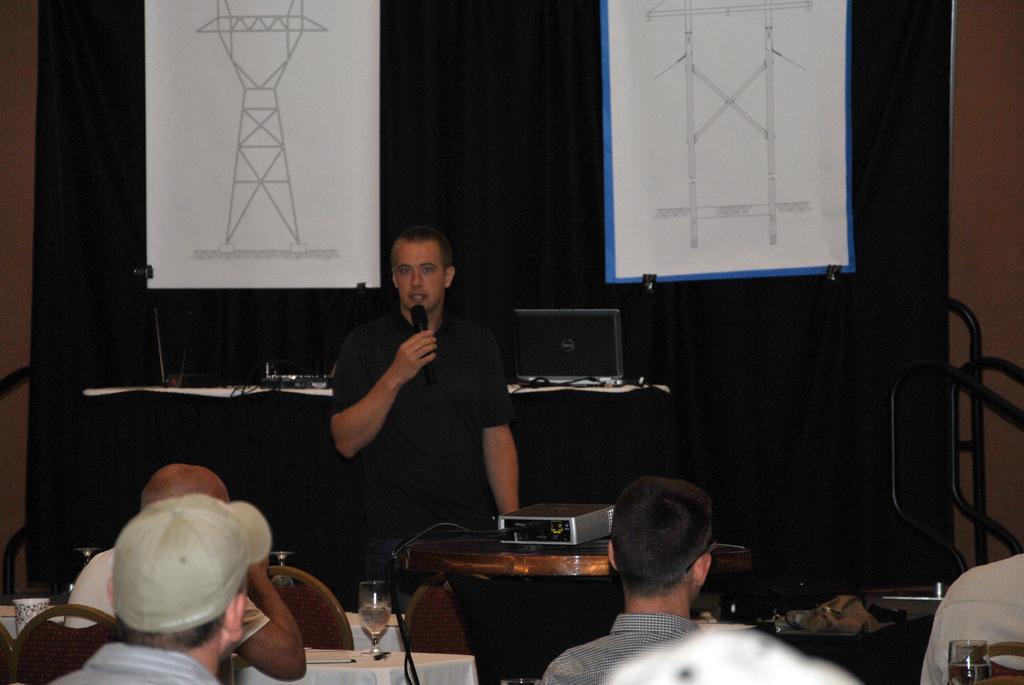Describe this image in one or two sentences. In this picture there is a man standing in front of a table on which a projector was placed holding a mic and talking. There are some people sitting and listening to him in the chairs. In the background there are some charts hanged in front of a curtain. 